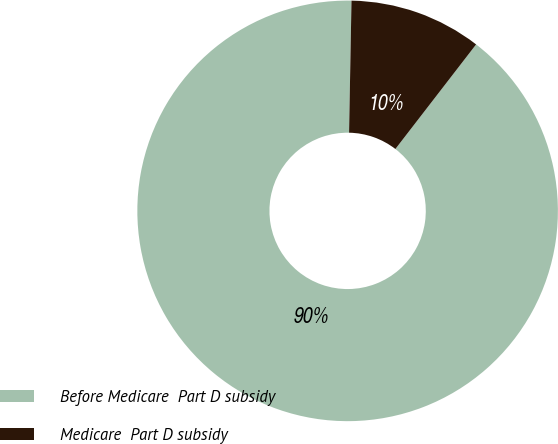<chart> <loc_0><loc_0><loc_500><loc_500><pie_chart><fcel>Before Medicare  Part D subsidy<fcel>Medicare  Part D subsidy<nl><fcel>89.83%<fcel>10.17%<nl></chart> 